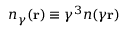Convert formula to latex. <formula><loc_0><loc_0><loc_500><loc_500>n _ { \gamma } ( { r } ) \equiv \gamma ^ { 3 } n ( \gamma { r } )</formula> 